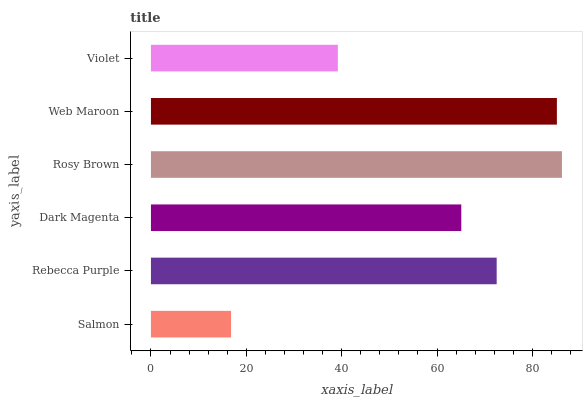Is Salmon the minimum?
Answer yes or no. Yes. Is Rosy Brown the maximum?
Answer yes or no. Yes. Is Rebecca Purple the minimum?
Answer yes or no. No. Is Rebecca Purple the maximum?
Answer yes or no. No. Is Rebecca Purple greater than Salmon?
Answer yes or no. Yes. Is Salmon less than Rebecca Purple?
Answer yes or no. Yes. Is Salmon greater than Rebecca Purple?
Answer yes or no. No. Is Rebecca Purple less than Salmon?
Answer yes or no. No. Is Rebecca Purple the high median?
Answer yes or no. Yes. Is Dark Magenta the low median?
Answer yes or no. Yes. Is Web Maroon the high median?
Answer yes or no. No. Is Salmon the low median?
Answer yes or no. No. 